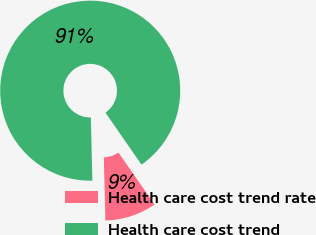<chart> <loc_0><loc_0><loc_500><loc_500><pie_chart><fcel>Health care cost trend rate<fcel>Health care cost trend<nl><fcel>9.27%<fcel>90.73%<nl></chart> 